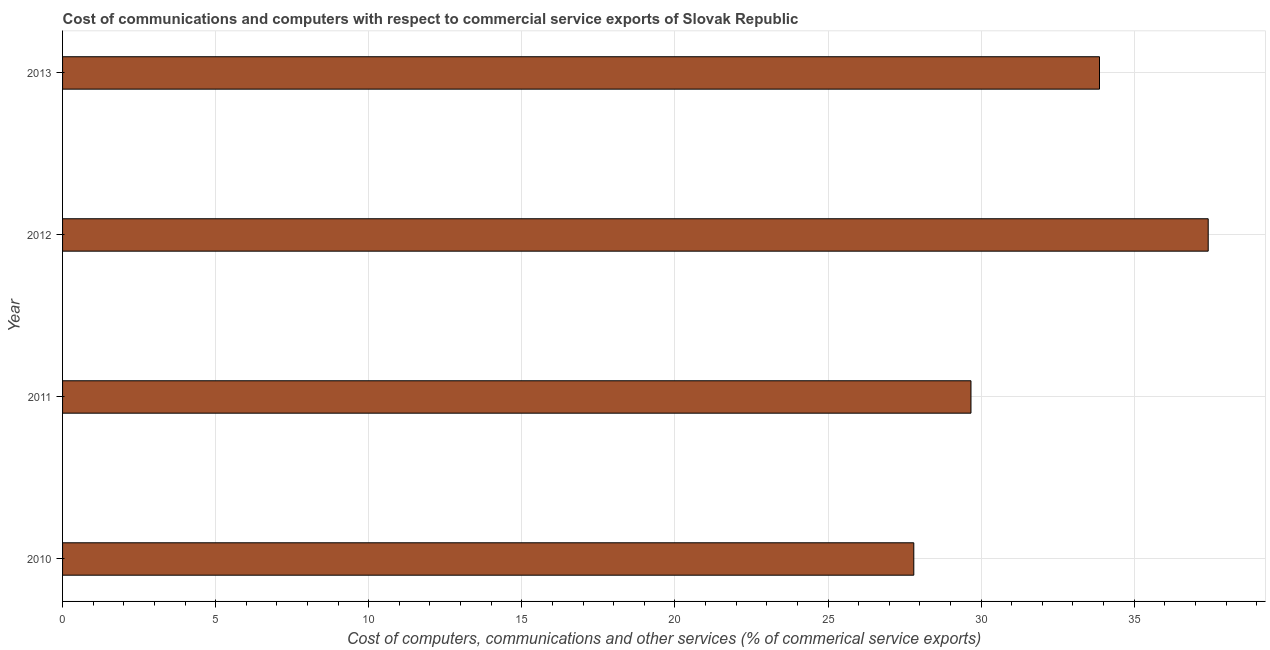Does the graph contain any zero values?
Ensure brevity in your answer.  No. Does the graph contain grids?
Offer a very short reply. Yes. What is the title of the graph?
Provide a succinct answer. Cost of communications and computers with respect to commercial service exports of Slovak Republic. What is the label or title of the X-axis?
Offer a terse response. Cost of computers, communications and other services (% of commerical service exports). What is the cost of communications in 2011?
Ensure brevity in your answer.  29.67. Across all years, what is the maximum  computer and other services?
Ensure brevity in your answer.  37.42. Across all years, what is the minimum  computer and other services?
Your answer should be compact. 27.8. In which year was the cost of communications maximum?
Make the answer very short. 2012. What is the sum of the cost of communications?
Provide a succinct answer. 128.76. What is the difference between the cost of communications in 2011 and 2013?
Provide a succinct answer. -4.2. What is the average  computer and other services per year?
Your answer should be compact. 32.19. What is the median cost of communications?
Ensure brevity in your answer.  31.77. What is the ratio of the  computer and other services in 2010 to that in 2011?
Offer a terse response. 0.94. Is the cost of communications in 2012 less than that in 2013?
Give a very brief answer. No. What is the difference between the highest and the second highest cost of communications?
Offer a very short reply. 3.55. Is the sum of the cost of communications in 2012 and 2013 greater than the maximum cost of communications across all years?
Your answer should be compact. Yes. What is the difference between the highest and the lowest  computer and other services?
Your response must be concise. 9.62. Are the values on the major ticks of X-axis written in scientific E-notation?
Keep it short and to the point. No. What is the Cost of computers, communications and other services (% of commerical service exports) in 2010?
Provide a succinct answer. 27.8. What is the Cost of computers, communications and other services (% of commerical service exports) in 2011?
Offer a very short reply. 29.67. What is the Cost of computers, communications and other services (% of commerical service exports) of 2012?
Ensure brevity in your answer.  37.42. What is the Cost of computers, communications and other services (% of commerical service exports) in 2013?
Your answer should be compact. 33.87. What is the difference between the Cost of computers, communications and other services (% of commerical service exports) in 2010 and 2011?
Your response must be concise. -1.87. What is the difference between the Cost of computers, communications and other services (% of commerical service exports) in 2010 and 2012?
Your answer should be very brief. -9.62. What is the difference between the Cost of computers, communications and other services (% of commerical service exports) in 2010 and 2013?
Offer a terse response. -6.07. What is the difference between the Cost of computers, communications and other services (% of commerical service exports) in 2011 and 2012?
Ensure brevity in your answer.  -7.75. What is the difference between the Cost of computers, communications and other services (% of commerical service exports) in 2011 and 2013?
Your answer should be compact. -4.2. What is the difference between the Cost of computers, communications and other services (% of commerical service exports) in 2012 and 2013?
Make the answer very short. 3.55. What is the ratio of the Cost of computers, communications and other services (% of commerical service exports) in 2010 to that in 2011?
Offer a very short reply. 0.94. What is the ratio of the Cost of computers, communications and other services (% of commerical service exports) in 2010 to that in 2012?
Offer a terse response. 0.74. What is the ratio of the Cost of computers, communications and other services (% of commerical service exports) in 2010 to that in 2013?
Offer a very short reply. 0.82. What is the ratio of the Cost of computers, communications and other services (% of commerical service exports) in 2011 to that in 2012?
Provide a short and direct response. 0.79. What is the ratio of the Cost of computers, communications and other services (% of commerical service exports) in 2011 to that in 2013?
Your answer should be compact. 0.88. What is the ratio of the Cost of computers, communications and other services (% of commerical service exports) in 2012 to that in 2013?
Keep it short and to the point. 1.1. 